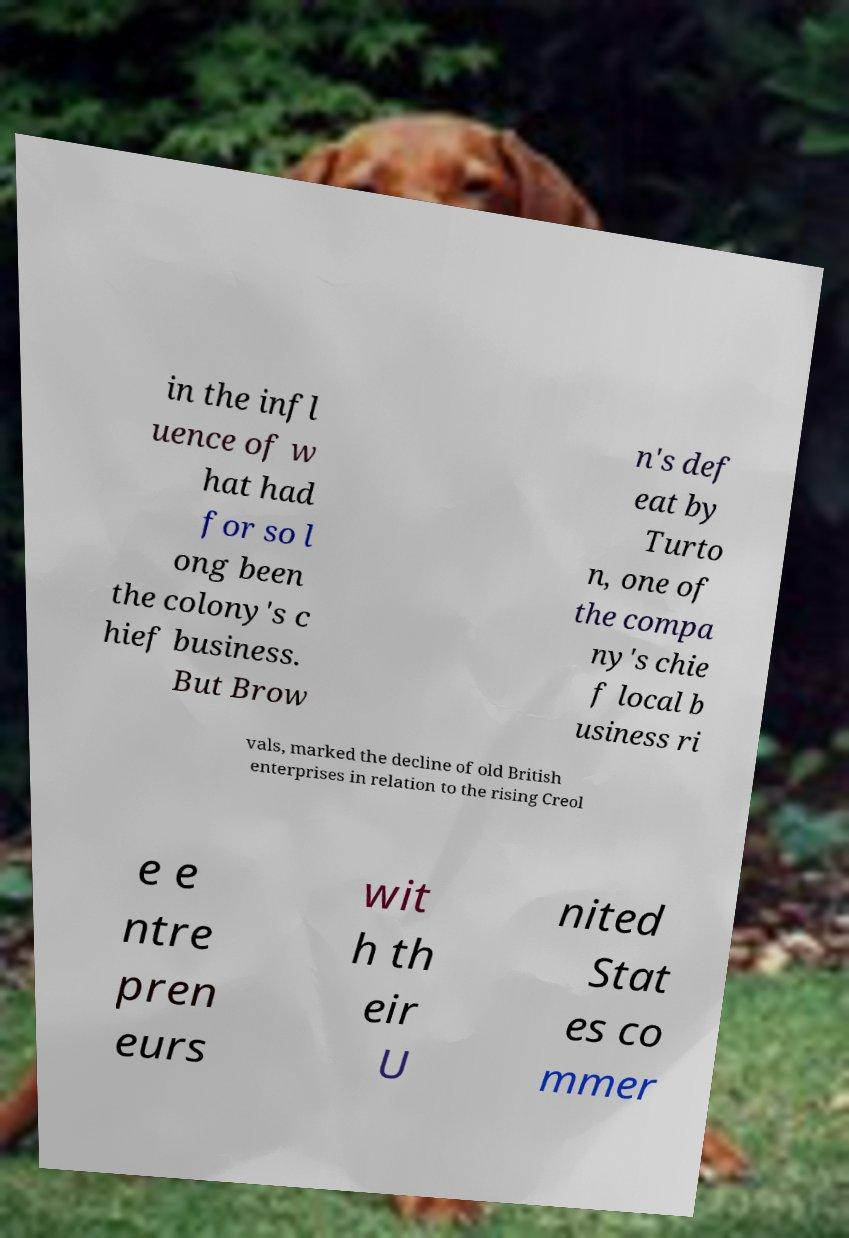Could you assist in decoding the text presented in this image and type it out clearly? in the infl uence of w hat had for so l ong been the colony's c hief business. But Brow n's def eat by Turto n, one of the compa ny's chie f local b usiness ri vals, marked the decline of old British enterprises in relation to the rising Creol e e ntre pren eurs wit h th eir U nited Stat es co mmer 